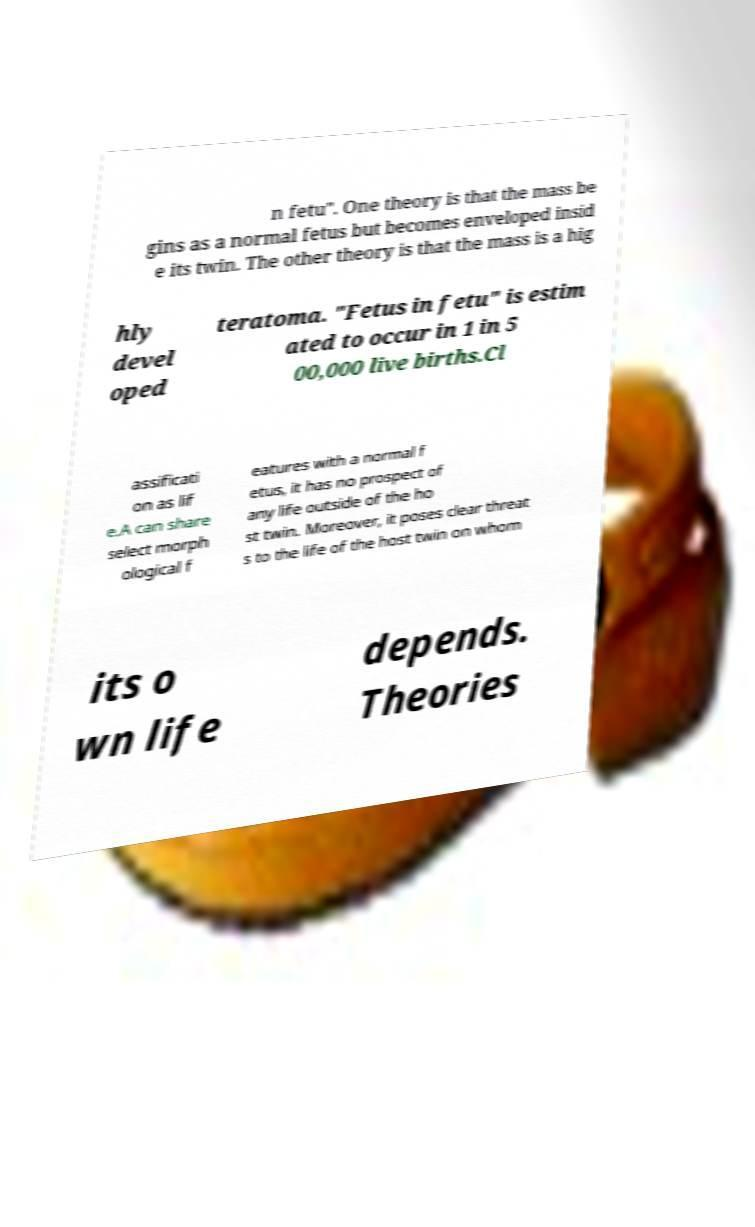For documentation purposes, I need the text within this image transcribed. Could you provide that? n fetu". One theory is that the mass be gins as a normal fetus but becomes enveloped insid e its twin. The other theory is that the mass is a hig hly devel oped teratoma. "Fetus in fetu" is estim ated to occur in 1 in 5 00,000 live births.Cl assificati on as lif e.A can share select morph ological f eatures with a normal f etus, it has no prospect of any life outside of the ho st twin. Moreover, it poses clear threat s to the life of the host twin on whom its o wn life depends. Theories 